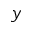<formula> <loc_0><loc_0><loc_500><loc_500>y</formula> 